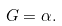Convert formula to latex. <formula><loc_0><loc_0><loc_500><loc_500>G = \alpha .</formula> 